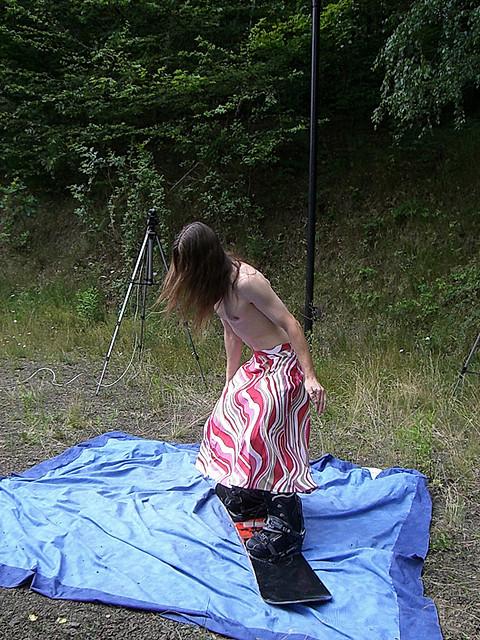What element is missing in this picture?
Short answer required. Snow. Is the subject male or female?
Answer briefly. Male. What is the pole in the background?
Write a very short answer. Light pole. 